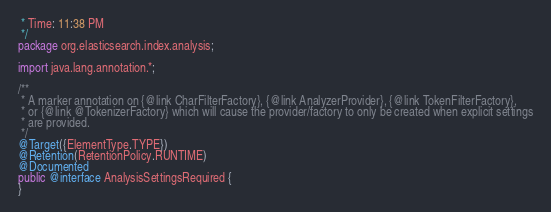<code> <loc_0><loc_0><loc_500><loc_500><_Java_> * Time: 11:38 PM
 */
package org.elasticsearch.index.analysis;

import java.lang.annotation.*;

/**
 * A marker annotation on {@link CharFilterFactory}, {@link AnalyzerProvider}, {@link TokenFilterFactory},
 * or {@link @TokenizerFactory} which will cause the provider/factory to only be created when explicit settings
 * are provided.
 */
@Target({ElementType.TYPE})
@Retention(RetentionPolicy.RUNTIME)
@Documented
public @interface AnalysisSettingsRequired {
}</code> 